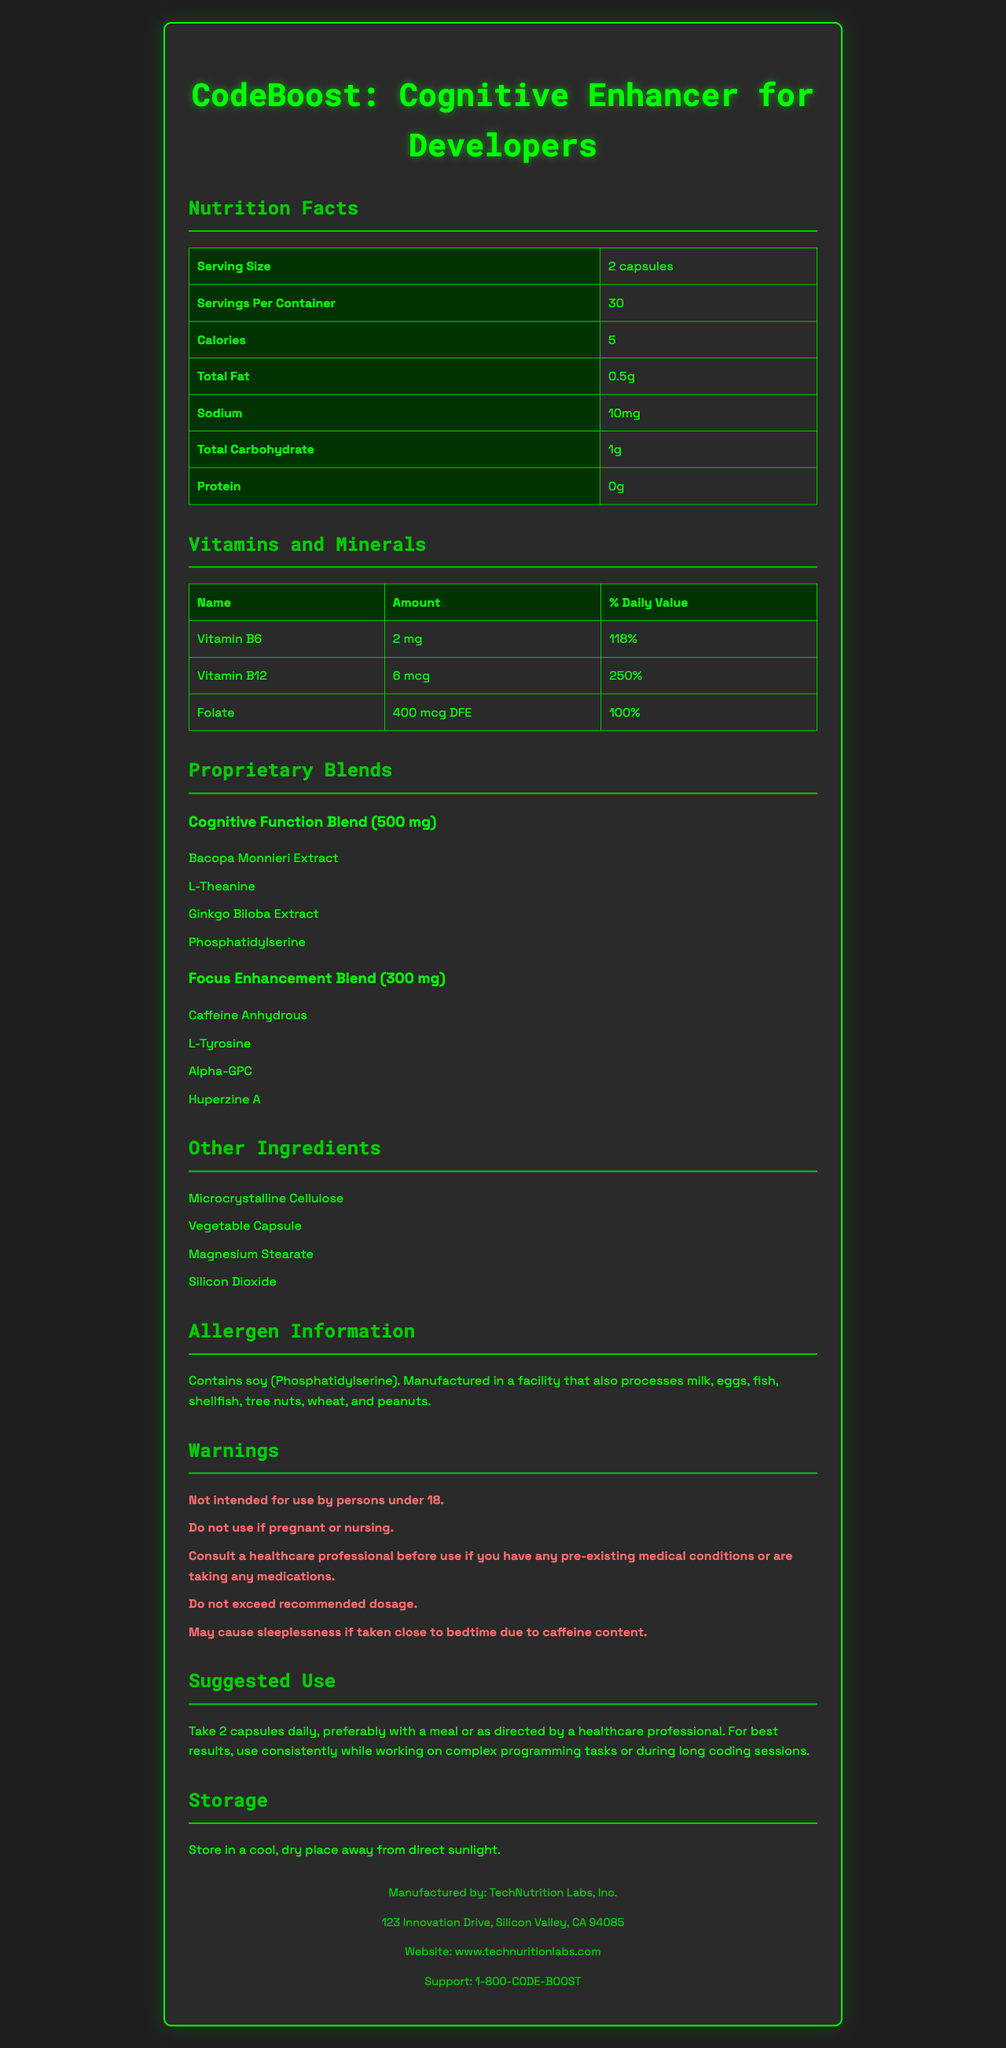what is the serving size? The serving size is indicated near the top of the Nutrition Facts under "Serving Size."
Answer: 2 capsules how many calories are in each serving? The calories per serving are listed next to "Calories" in the Nutrition Facts section.
Answer: 5 how much Vitamin B12 is in each serving? The amount of Vitamin B12 is listed under "Vitamins and Minerals" as "6 mcg."
Answer: 6 mcg What percentage of the daily value for Folate does each serving contain? The percentage of the daily value for Folate is listed under "Vitamins and Minerals" as "100%."
Answer: 100% what are the main ingredients in the Cognitive Function Blend? The ingredients for the "Cognitive Function Blend" are listed in the Proprietary Blends section.
Answer: Bacopa Monnieri Extract, L-Theanine, Ginkgo Biloba Extract, Phosphatidylserine Which of the following ingredients are in the Focus Enhancement Blend? A. L-Theanine B. Bacopa Monnieri Extract C. Caffeine Anhydrous D. Phosphatidylserine From the Proprietary Blends section, "Caffeine Anhydrous" is part of the Focus Enhancement Blend.
Answer: C What is the total amount of Sodium in each serving? A. 0 mg B. 5 mg C. 10 mg D. 20 mg The Sodium content per serving is indicated as "10 mg" in the Nutrition Facts.
Answer: C Does the product contain any allergens? The Allergen Information section indicates that the product contains soy (Phosphatidylserine).
Answer: Yes Is this product recommended for pregnant women? The Warnings section specifically states "Do not use if pregnant or nursing."
Answer: No Summarize the key information provided in the document. The document provides detailed nutrition facts, ingredient information, warnings, suggested use, and manufacturer contact details for the dietary supplement "CodeBoost: Cognitive Enhancer for Developers."
Answer: "CodeBoost: Cognitive Enhancer for Developers" is a supplement aimed at enhancing cognitive function for developers. Each serving consists of 2 capsules, containing 5 calories, various vitamins with substantial percentages of daily values, and proprietary blends for cognitive function and focus enhancement. The product contains soy and is manufactured in a facility that processes various allergens. There are warnings for use regarding age, health conditions, and dosage, and it is not recommended for pregnant or nursing women. The manufacturer provides storage recommendations and contact information. How many capsules are suggested to be taken daily? The Suggested Use section advises taking 2 capsules daily.
Answer: 2 What is the exact address of the manufacturer? The address of the manufacturer is listed towards the end of the document.
Answer: 123 Innovation Drive, Silicon Valley, CA 94085 Who produces this supplement? The manufacturer's name is provided in the footer of the document.
Answer: TechNutrition Labs, Inc. Are the ingredients in the Cognitive Function Blend and Focus Enhancement Blend natural or synthetic? The document provides a list of ingredients but does not specify whether they are natural or synthetic.
Answer: Cannot be determined 